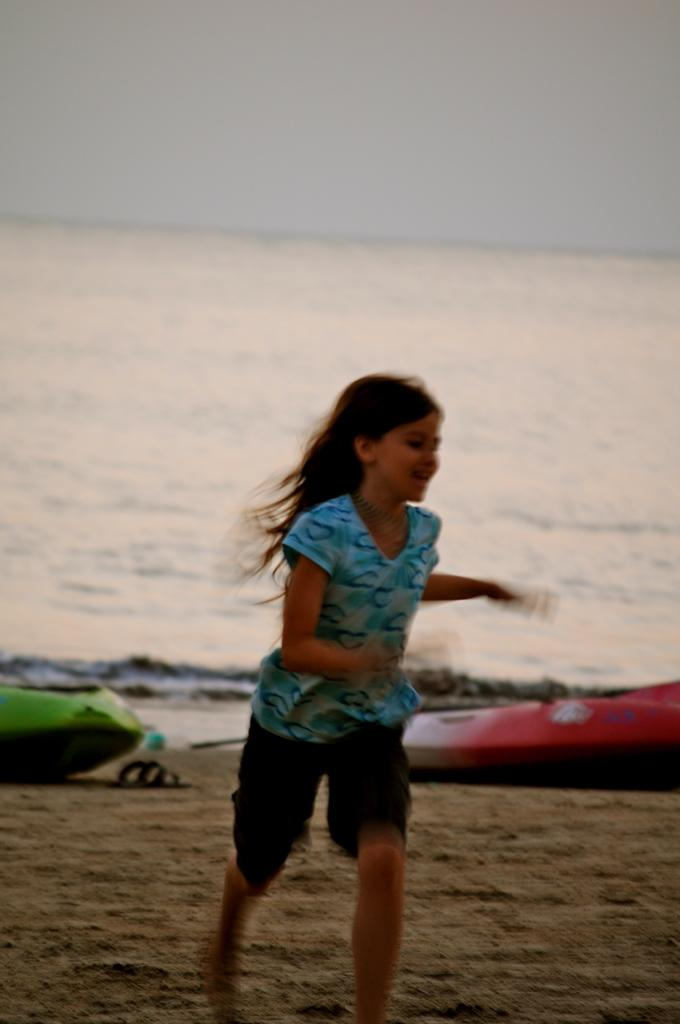Who is present in the image? There is a girl in the image. What is the girl doing in the image? The girl is running on sand in the image. What can be seen in the background of the image? The sky is visible in the background of the image. What type of footwear is present in the image? There is footwear in the image. What else can be seen in the image besides the girl? There are boats, water, and some objects visible in the image. How many babies are playing with the trees in the image? There are no babies or trees present in the image. What type of error can be seen in the image? There is no error visible in the image. 